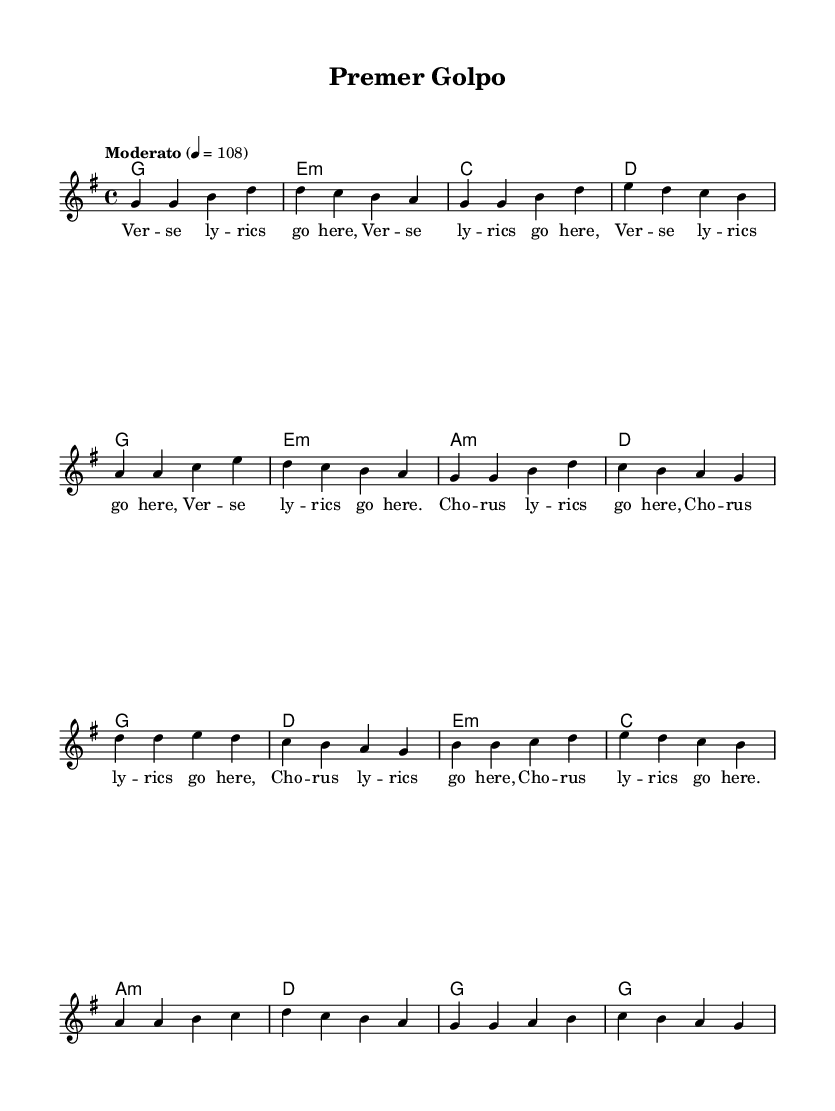What is the key signature of this music? The key signature is G major, which has one sharp (F#). This is indicated at the beginning of the music score where the key signature is shown.
Answer: G major What is the time signature of this music? The time signature is 4/4, shown at the beginning of the score. This means there are four beats in each measure, and the quarter note gets one beat.
Answer: 4/4 What is the tempo marking for this piece? The tempo marking is "Moderato" with a speed of 4 = 108, indicating a moderate speed for the music played at 108 beats per minute.
Answer: Moderato How many measures does the verse section contain? The verse section contains exactly 8 measures, as indicated by the grouping of the notes and the structure laid out in the sheet music.
Answer: 8 Which chords accompany the chorus section? The chords accompanying the chorus section are G, D, E minor, and C, as these are explicitly stated in the chord mode section alongside the melody.
Answer: G, D, E minor, C What is the lyrical form used in the lyrics of this song? The lyrical form consists of verses followed by a chorus, repeated throughout the piece, which is a common structure in pop music to emphasize the main themes of the song.
Answer: Verse-Chorus What kind of music is represented by this score? This score represents modern Bollywood-inspired Bangladeshi pop music, characterized by its intricate storylines reflected in verses and choruses, common in contemporary cultural expressions.
Answer: Modern Bollywood-inspired Bangladeshi pop music 